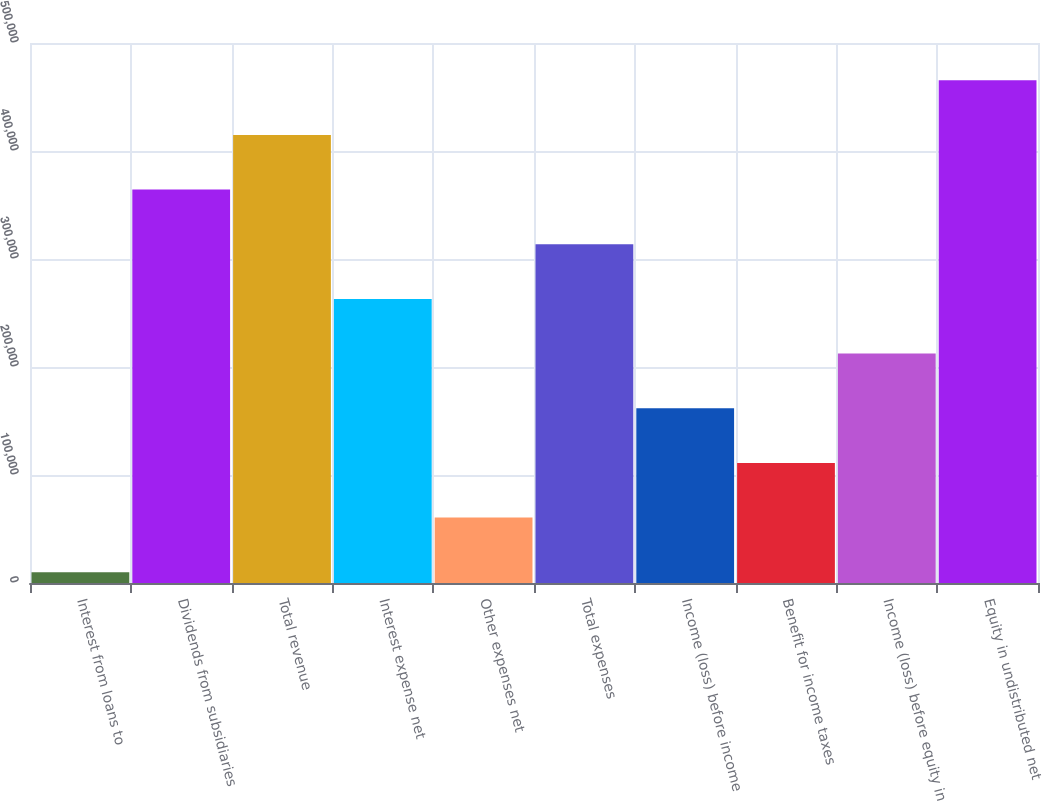Convert chart. <chart><loc_0><loc_0><loc_500><loc_500><bar_chart><fcel>Interest from loans to<fcel>Dividends from subsidiaries<fcel>Total revenue<fcel>Interest expense net<fcel>Other expenses net<fcel>Total expenses<fcel>Income (loss) before income<fcel>Benefit for income taxes<fcel>Income (loss) before equity in<fcel>Equity in undistributed net<nl><fcel>9988<fcel>364294<fcel>414910<fcel>263064<fcel>60603.2<fcel>313679<fcel>161834<fcel>111218<fcel>212449<fcel>465525<nl></chart> 